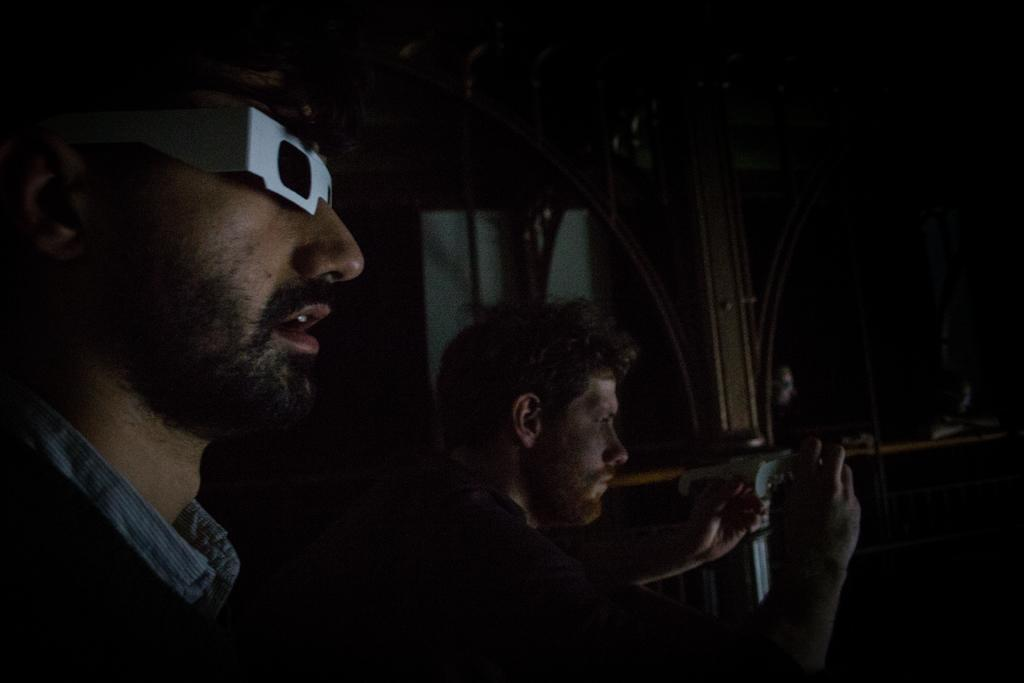How many people are in the image? There are people in the image, but the exact number is not specified. Can you describe any specific features of one of the people? One person is wearing glasses. What is another person doing in the image? Another person is holding an object. What can be seen in the background of the image? There are rods visible in the background of the image, as well as other objects. How does the jelly increase in size in the image? There is no jelly present in the image, so it cannot increase in size. 